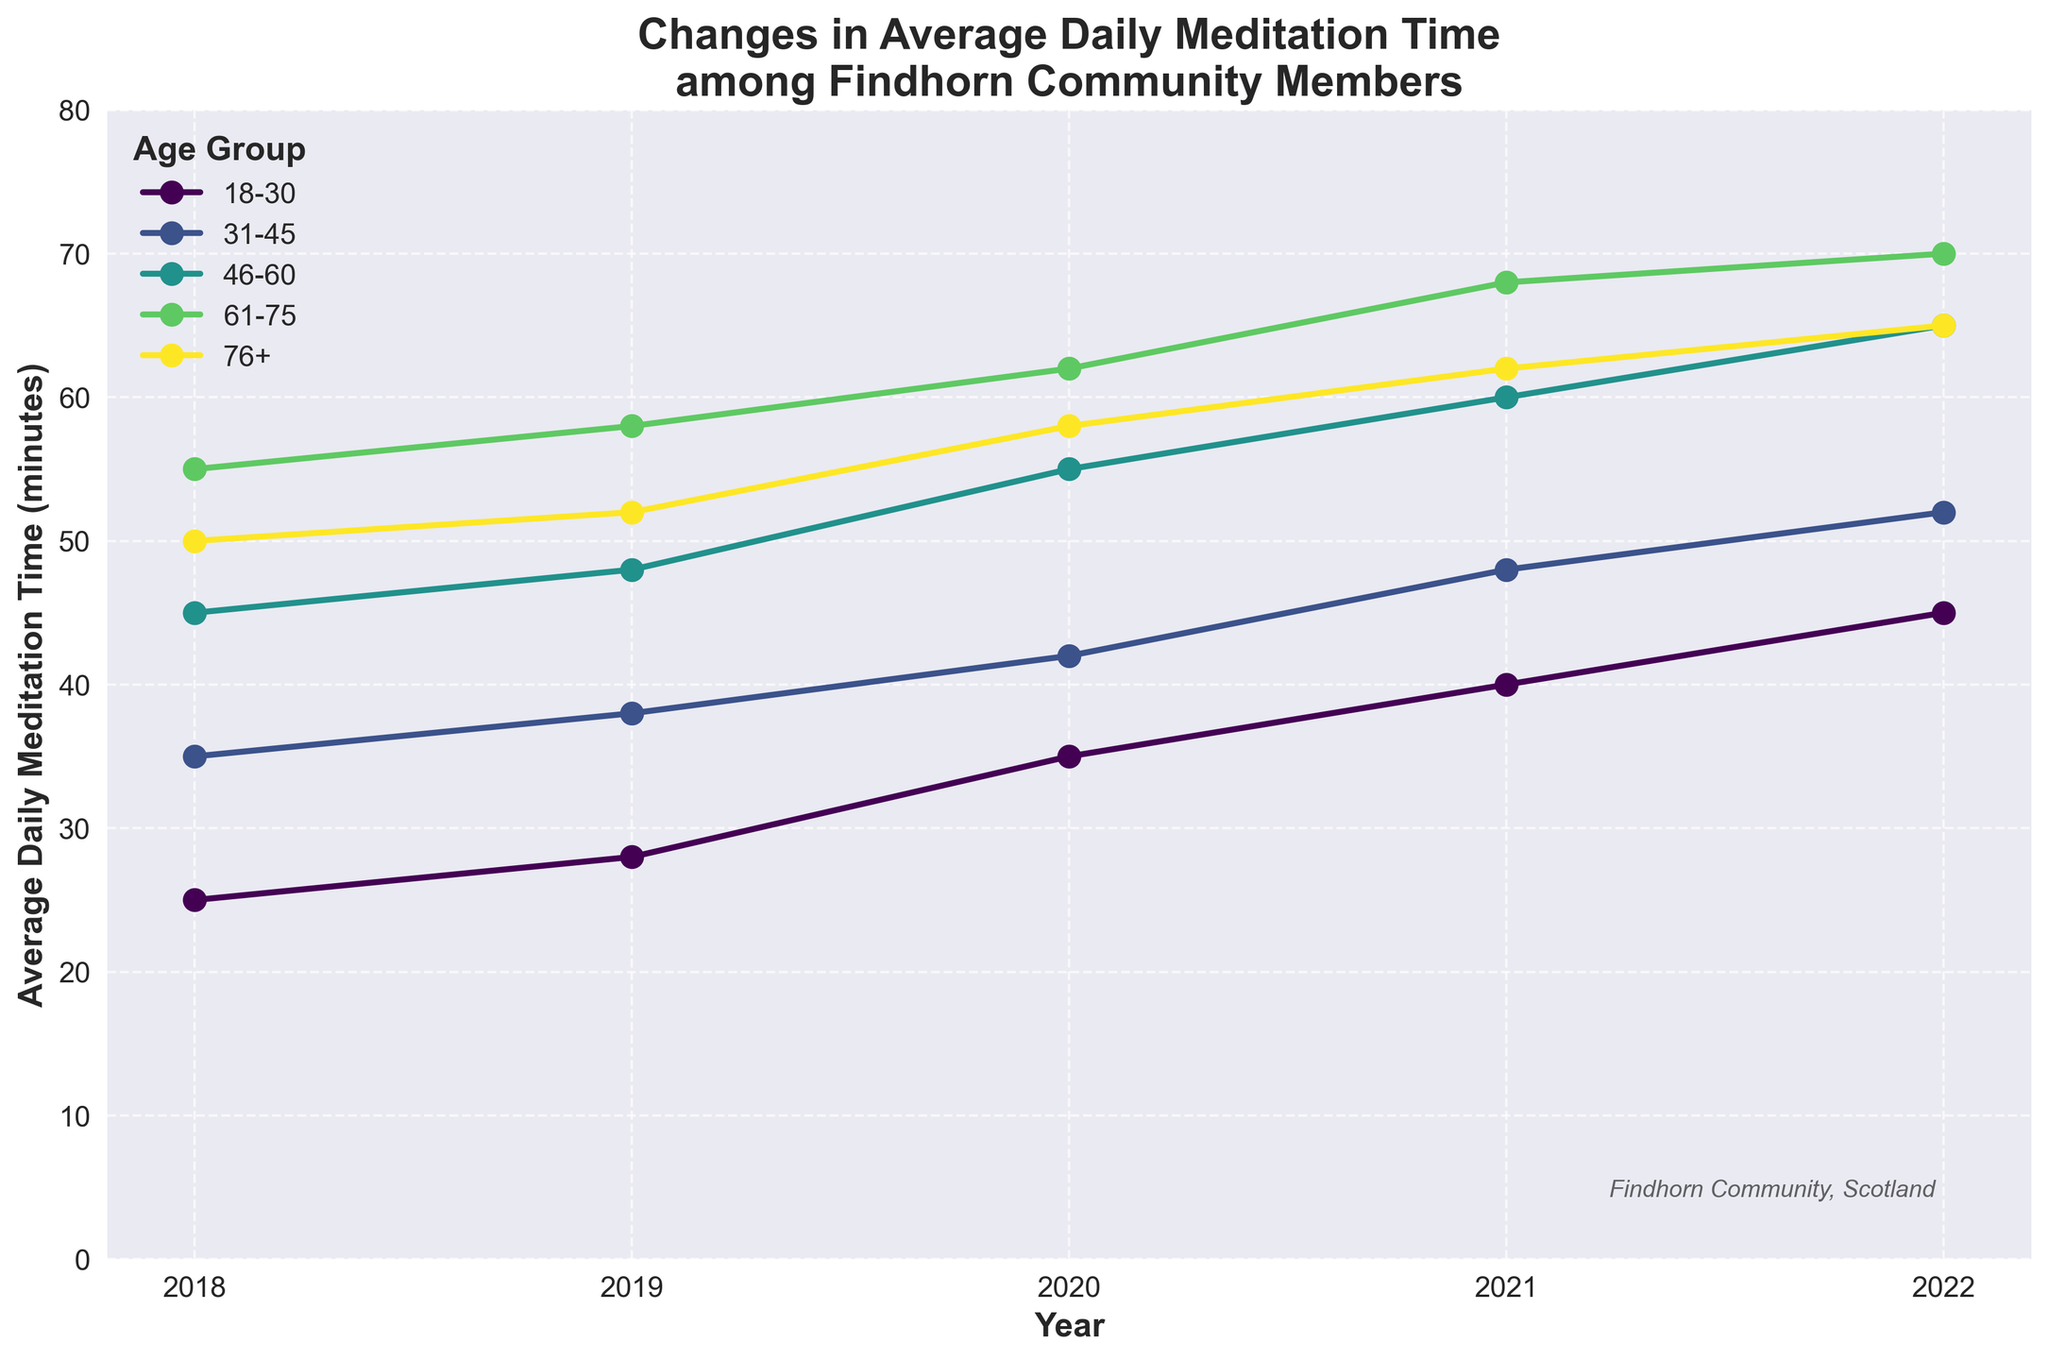What was the change in average daily meditation time for the age group 18-30 from 2018 to 2022? The average daily meditation time for the age group 18-30 was 25 minutes in 2018 and increased to 45 minutes in 2022. Thus, the change is 45 - 25 = 20 minutes.
Answer: 20 minutes Which age group had the highest average daily meditation time in 2022? The age group 61-75 had the highest average daily meditation time in 2022, which was 70 minutes.
Answer: 61-75 Compare the average daily meditation time between the age groups 31-45 and 46-60 in 2020. Which group spent more time? In 2020, the age group 31-45 had an average daily meditation time of 42 minutes, while the age group 46-60 had 55 minutes. The 46-60 age group spent more time meditating.
Answer: 46-60 What is the overall trend of average daily meditation time across all age groups from 2018 to 2022? For all age groups, the average daily meditation time shows an increasing trend over the years from 2018 to 2022.
Answer: Increasing How much did the average daily meditation time increase for the age group 76+ from 2019 to 2021? The average daily meditation time for the age group 76+ was 52 minutes in 2019 and 62 minutes in 2021. Therefore, the increase is 62 - 52 = 10 minutes.
Answer: 10 minutes Which age group saw the largest increase in average daily meditation time between 2018 and 2022? The age group 46-60 increased from 45 minutes in 2018 to 65 minutes in 2022, which is an increase of 20 minutes. No other group saw a larger increase.
Answer: 46-60 In which year did the age group 31-45 experience the highest increase in average daily meditation time compared to the previous year? The age group 31-45 had the highest increase in meditation time between 2021 (48 minutes) and 2022 (52 minutes). The increase was 52 - 48 = 4 minutes.
Answer: 2022 Does any age group have a consistent year-on-year increase in average daily meditation time from 2018 to 2022? The age groups 18-30, 31-45, 46-60, and 61-75 all show a consistent year-on-year increase in average daily meditation time from 2018 to 2022.
Answer: Yes What was the average daily meditation time for the age group 61-75 in 2020 compared to 2018? In 2020, the average daily meditation time for the age group 61-75 was 62 minutes, while in 2018 it was 55 minutes. So, the increase is 62 - 55 = 7 minutes.
Answer: 7 minutes Which age group shows the least variation in average daily meditation time over the 5-year period? The age group 76+ shows the least variation in average daily meditation time, with a range from 50 minutes in 2018 to 65 minutes in 2022.
Answer: 76+ 